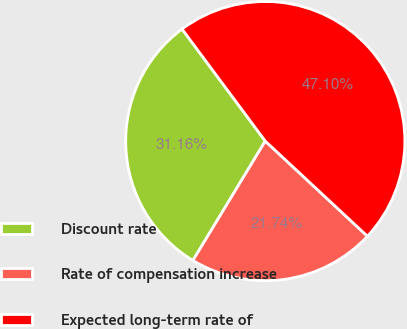Convert chart to OTSL. <chart><loc_0><loc_0><loc_500><loc_500><pie_chart><fcel>Discount rate<fcel>Rate of compensation increase<fcel>Expected long-term rate of<nl><fcel>31.16%<fcel>21.74%<fcel>47.1%<nl></chart> 